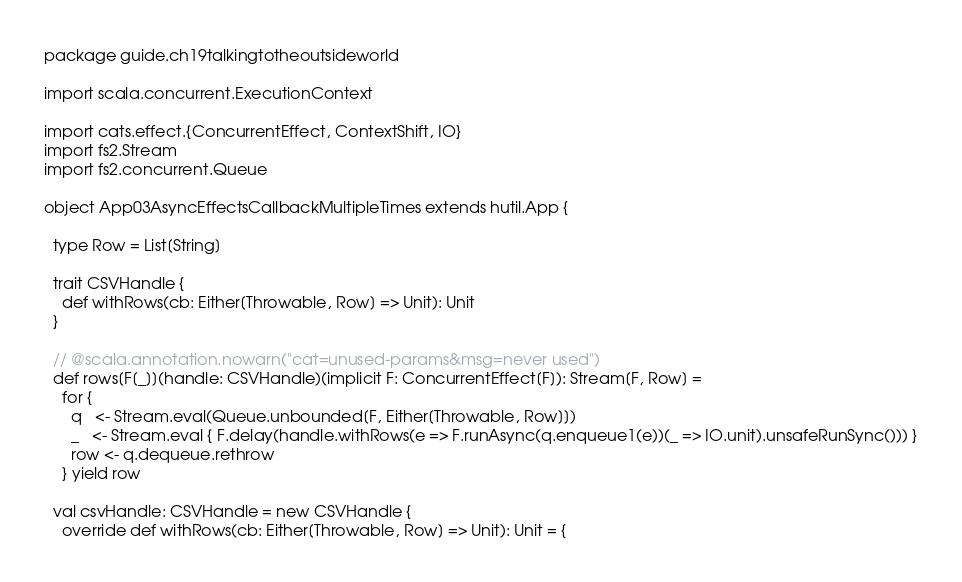<code> <loc_0><loc_0><loc_500><loc_500><_Scala_>package guide.ch19talkingtotheoutsideworld

import scala.concurrent.ExecutionContext

import cats.effect.{ConcurrentEffect, ContextShift, IO}
import fs2.Stream
import fs2.concurrent.Queue

object App03AsyncEffectsCallbackMultipleTimes extends hutil.App {

  type Row = List[String]

  trait CSVHandle {
    def withRows(cb: Either[Throwable, Row] => Unit): Unit
  }

  // @scala.annotation.nowarn("cat=unused-params&msg=never used")
  def rows[F[_]](handle: CSVHandle)(implicit F: ConcurrentEffect[F]): Stream[F, Row] =
    for {
      q   <- Stream.eval(Queue.unbounded[F, Either[Throwable, Row]])
      _   <- Stream.eval { F.delay(handle.withRows(e => F.runAsync(q.enqueue1(e))(_ => IO.unit).unsafeRunSync())) }
      row <- q.dequeue.rethrow
    } yield row

  val csvHandle: CSVHandle = new CSVHandle {
    override def withRows(cb: Either[Throwable, Row] => Unit): Unit = {</code> 